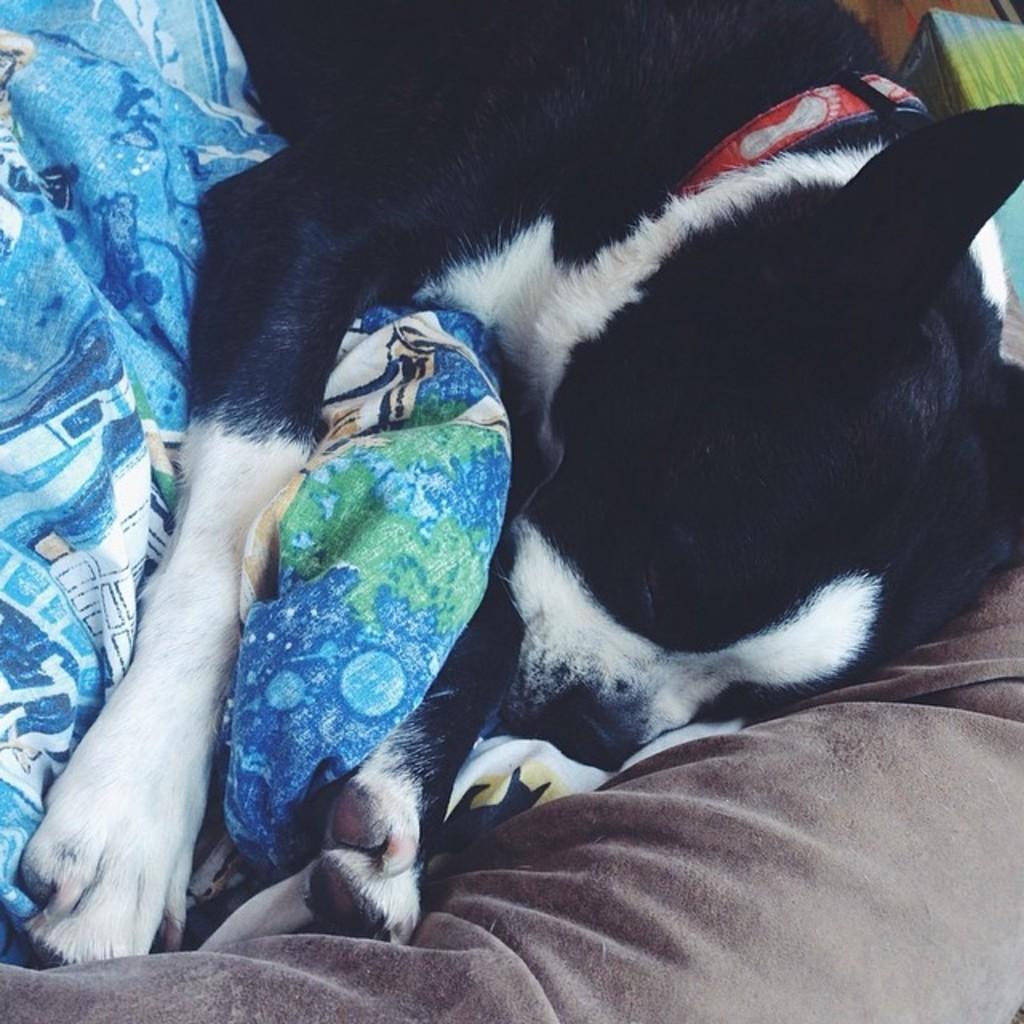How would you summarize this image in a sentence or two? In this image I can see a black and white colour dog. I can also see this dog is wearing a red colour belt around the neck. Under the dog I can see a blue and white colour cloth. On the bottom side of the image I can see a cushion like thing. 